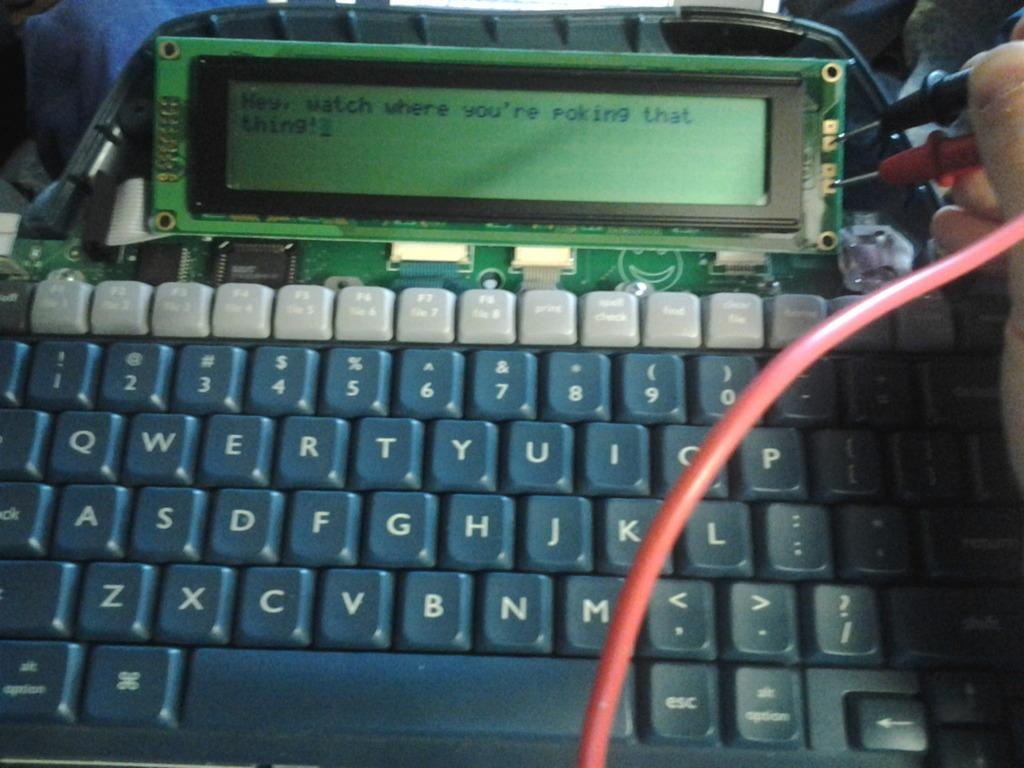Provide a one-sentence caption for the provided image. A computer read out warns a person to watch where they're poking. 